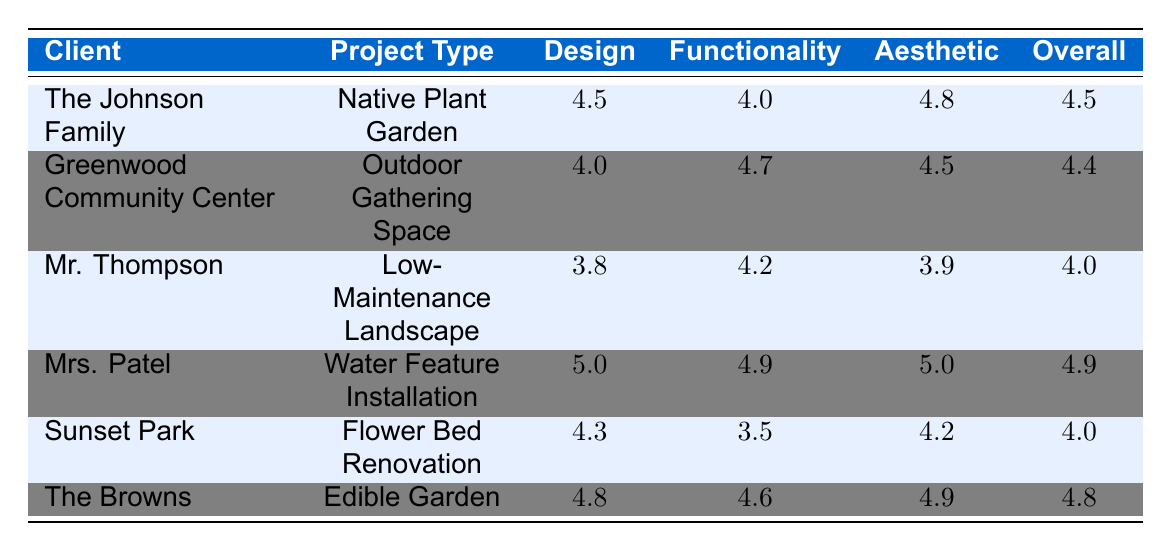What is the overall satisfaction rating for Mrs. Patel? By referring directly to the table, we find Mrs. Patel's Overall Satisfaction column has a value of 4.9.
Answer: 4.9 Which project type received the lowest design rating? By checking each Design Rating value in the table, we note Mr. Thompson's Low-Maintenance Landscape has the lowest rating at 3.8.
Answer: Low-Maintenance Landscape What is the average aesthetic rating across all projects? To calculate the average aesthetic rating, we sum the aesthetic ratings: (4.8 + 4.5 + 3.9 + 5.0 + 4.2 + 4.9) = 27.3. There are 6 projects, so we divide: 27.3 / 6 = 4.55.
Answer: 4.55 Did the Johnson Family express satisfaction with the functionality of their native plant garden? The Design and Functionality ratings for the Johnson Family are 4.5 and 4.0, respectively. Since 4.0 indicates reasonable approval, we can conclude they likely expressed satisfaction with functionality.
Answer: Yes Which project type has the highest overall satisfaction rating and what is that rating? By comparing the Overall Satisfaction rows, we note the Water Feature Installation (Mrs. Patel) has the highest rating of 4.9.
Answer: Water Feature Installation, 4.9 What is the difference between the design rating for the Edible Garden and the design rating for the Outdoor Gathering Space? The Edible Garden has a Design Rating of 4.8 and the Outdoor Gathering Space has a Design Rating of 4.0. The difference is calculated as 4.8 - 4.0 = 0.8.
Answer: 0.8 Did any project receive a functionality rating below 4.0? By reviewing the Functionality ratings, we see that Sunset Park's Flower Bed Renovation has a rating of 3.5, which is below 4.0.
Answer: Yes What could be inferred about the attractiveness of the flower bed renovation based on the aesthetic rating? The Flower Bed Renovation has an Aesthetic Rating of 4.2, which suggests it is considered attractive, albeit not the highest among the projects.
Answer: Fairly attractive What are the satisfaction ratings (overall and design) for the Johnson Family's project? The Johnson Family's Native Plant Garden has an Overall Satisfaction of 4.5 and a Design Rating of 4.5.
Answer: 4.5, 4.5 